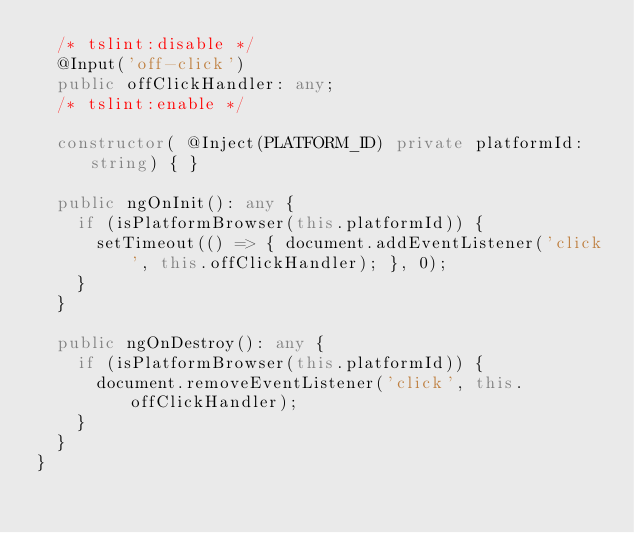<code> <loc_0><loc_0><loc_500><loc_500><_TypeScript_>  /* tslint:disable */
  @Input('off-click')
  public offClickHandler: any;
  /* tslint:enable */

  constructor( @Inject(PLATFORM_ID) private platformId: string) { }

  public ngOnInit(): any {
    if (isPlatformBrowser(this.platformId)) {
      setTimeout(() => { document.addEventListener('click', this.offClickHandler); }, 0);
    }
  }

  public ngOnDestroy(): any {
    if (isPlatformBrowser(this.platformId)) {
      document.removeEventListener('click', this.offClickHandler);
    }
  }
}
</code> 